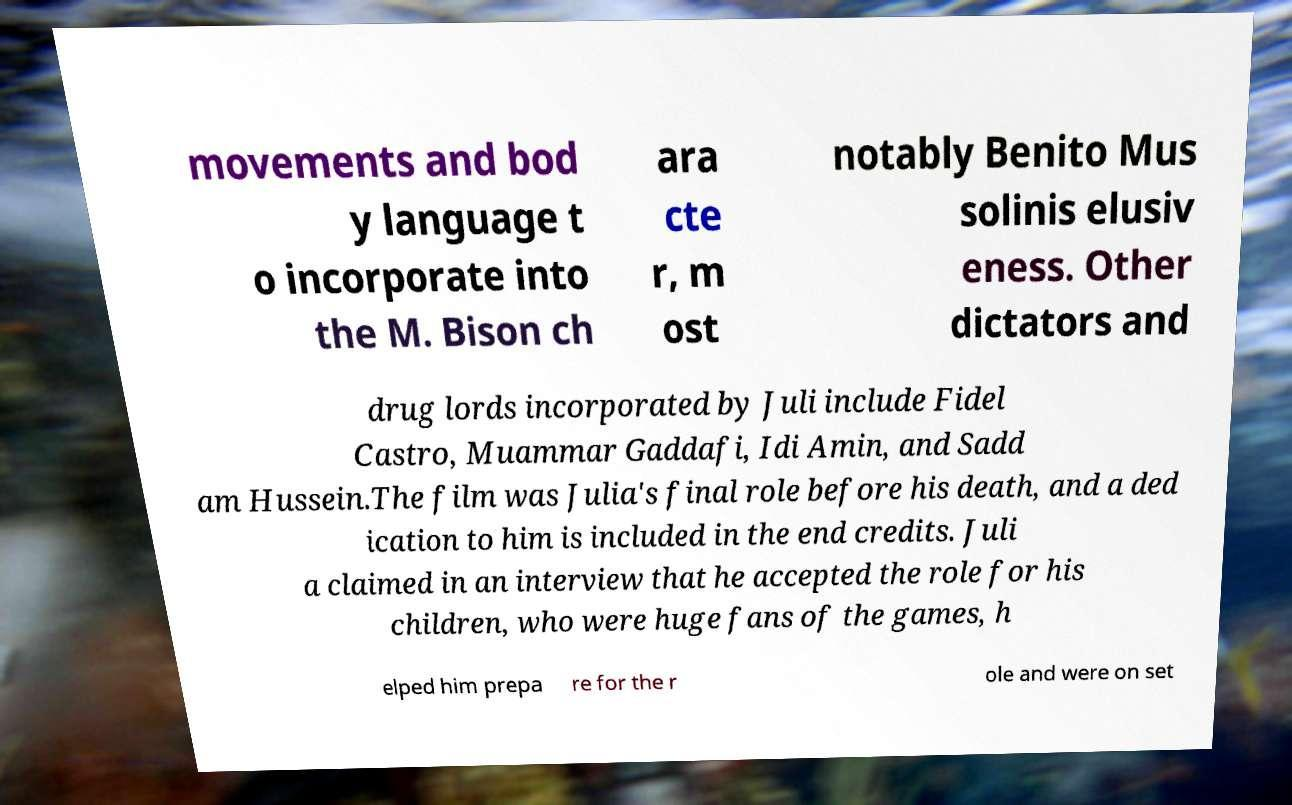Please read and relay the text visible in this image. What does it say? movements and bod y language t o incorporate into the M. Bison ch ara cte r, m ost notably Benito Mus solinis elusiv eness. Other dictators and drug lords incorporated by Juli include Fidel Castro, Muammar Gaddafi, Idi Amin, and Sadd am Hussein.The film was Julia's final role before his death, and a ded ication to him is included in the end credits. Juli a claimed in an interview that he accepted the role for his children, who were huge fans of the games, h elped him prepa re for the r ole and were on set 